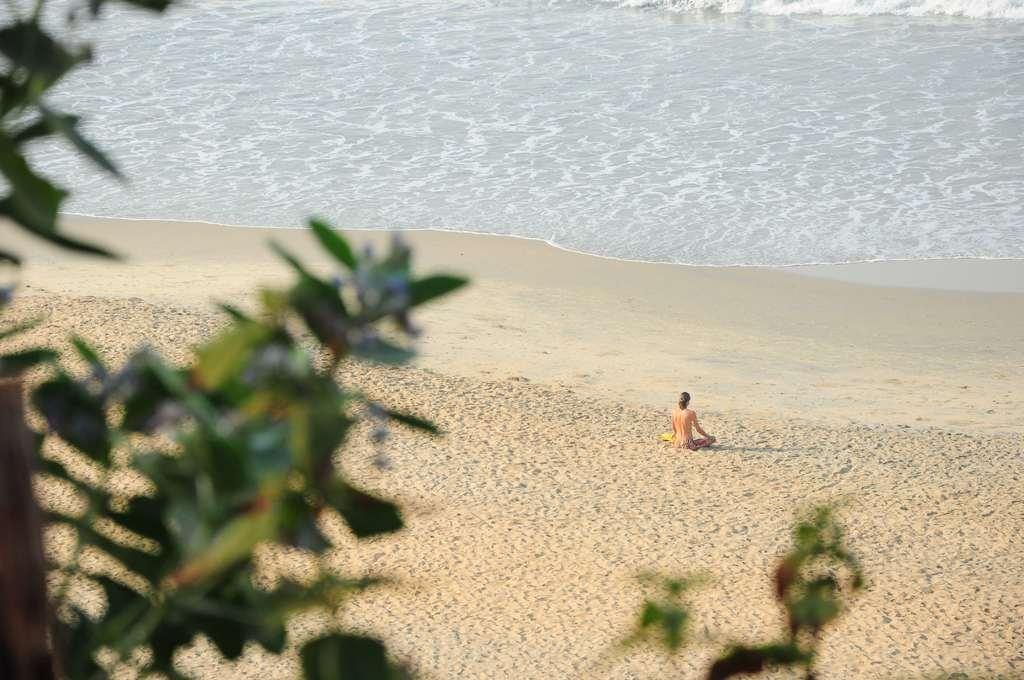What is located on the left side of the image? There is a tree on the left side of the image. What is the woman in the image doing? The woman is sitting on the sand. What can be seen in the background of the image? There is water visible in the background of the image. Can you see any badges on the woman in the image? There is no mention of a badge in the image, so it cannot be determined if one is present. Are there any cobwebs visible in the image? There is no mention of cobwebs in the image, so it cannot be determined if any are present. 